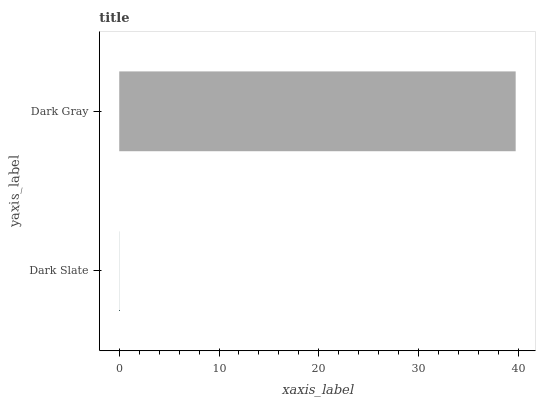Is Dark Slate the minimum?
Answer yes or no. Yes. Is Dark Gray the maximum?
Answer yes or no. Yes. Is Dark Gray the minimum?
Answer yes or no. No. Is Dark Gray greater than Dark Slate?
Answer yes or no. Yes. Is Dark Slate less than Dark Gray?
Answer yes or no. Yes. Is Dark Slate greater than Dark Gray?
Answer yes or no. No. Is Dark Gray less than Dark Slate?
Answer yes or no. No. Is Dark Gray the high median?
Answer yes or no. Yes. Is Dark Slate the low median?
Answer yes or no. Yes. Is Dark Slate the high median?
Answer yes or no. No. Is Dark Gray the low median?
Answer yes or no. No. 